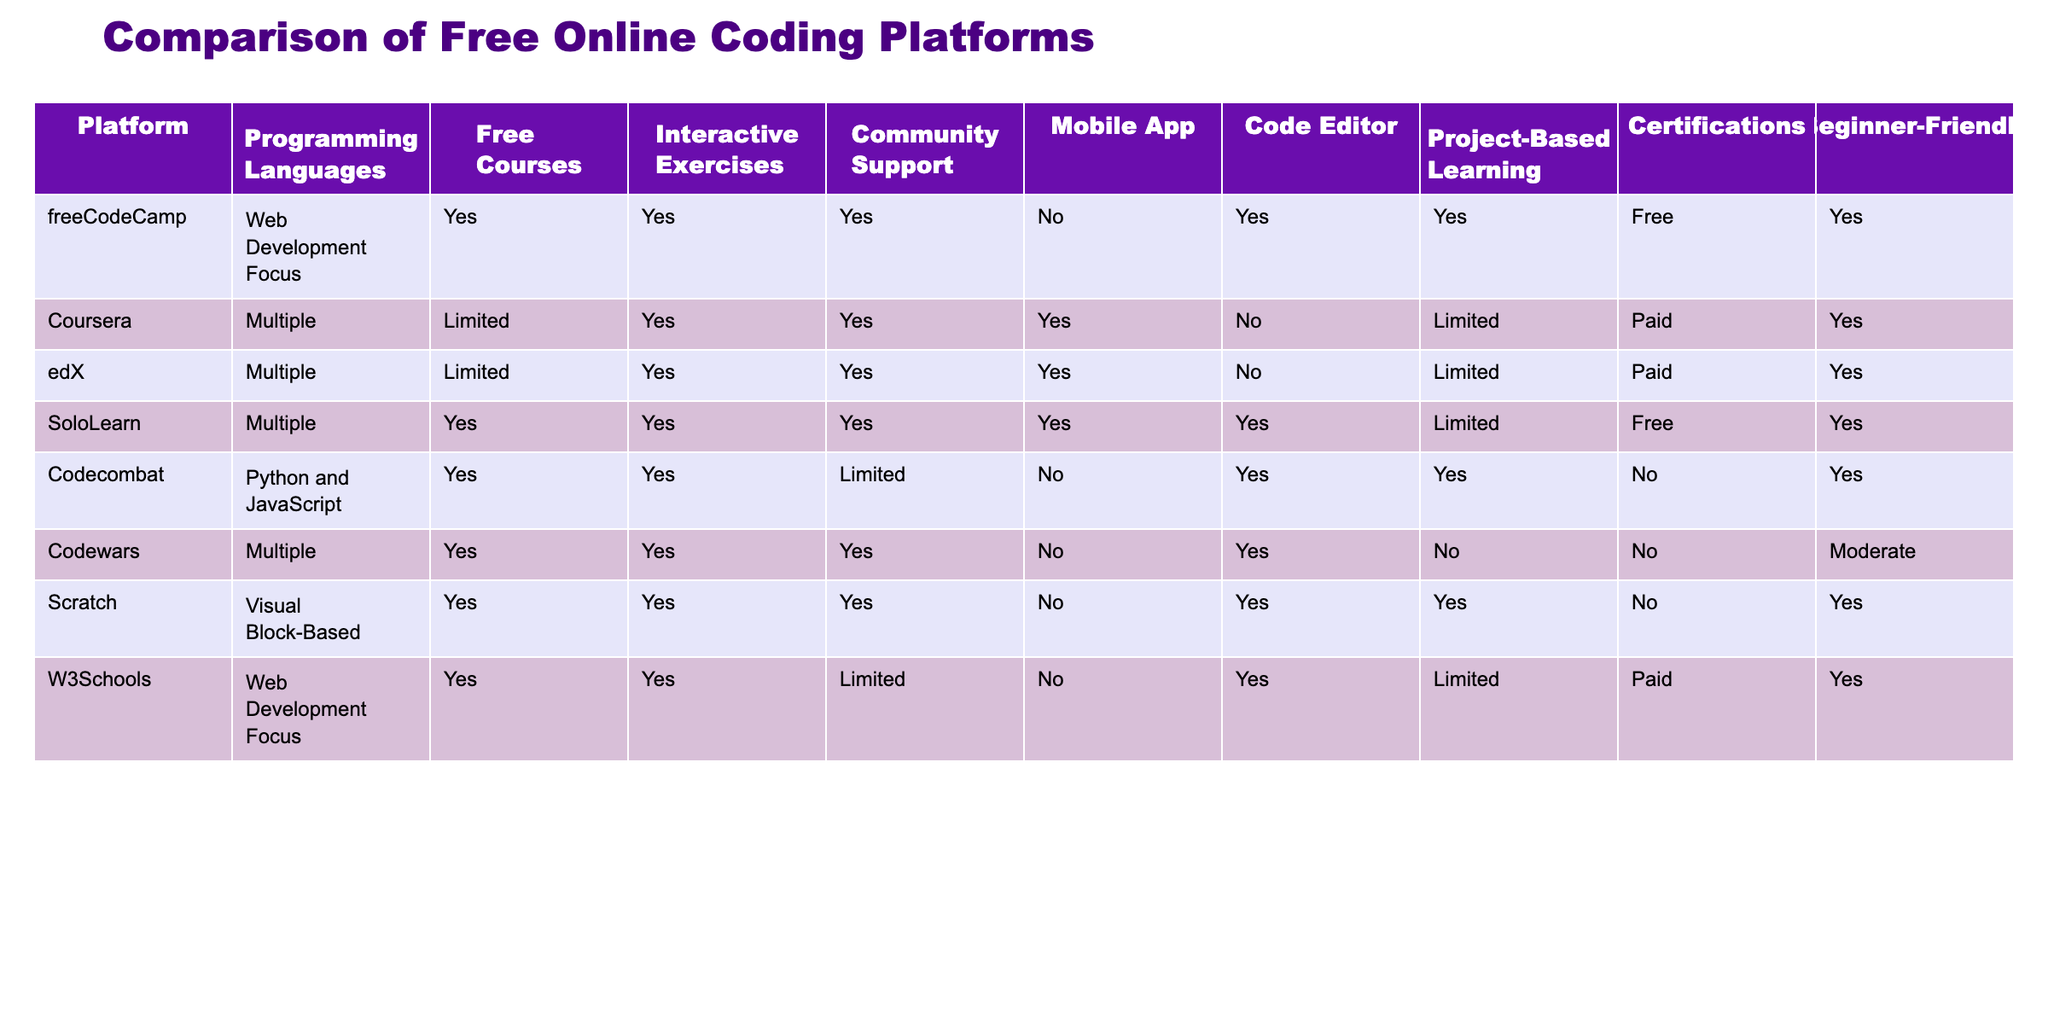What platforms offer project-based learning? By examining the column labeled "Project-Based Learning," I see which platforms have "Yes" listed. These platforms are freeCodeCamp, Codecombat, Scratch, and SoloLearn.
Answer: freeCodeCamp, Codecombat, Scratch, SoloLearn How many platforms provide a mobile app? I will count the platforms where the "Mobile App" column is marked "Yes." By scanning the data, I find that SoloLearn, Coursera, and edX provide a mobile app. This totals to three platforms.
Answer: 3 Is Scratch beginner-friendly? I will check the "Beginner-Friendly" column for Scratch and see that it indicates "Yes," meaning it is indeed beginner-friendly.
Answer: Yes Which platform has the most comprehensive community support? Looking at the "Community Support" column, I can see that "Yes" is noted for SoloLearn, freeCodeCamp, and Codewars. Among these, SoloLearn appears to have the most strong community support as indicated by the presence in multiple categories.
Answer: SoloLearn How many platforms do not offer certifications? By counting the entries in the "Certifications" column marked as "No," I find that Codecombat, Scratch, and Codewars have "No" listed under certifications. This shows that there are three platforms that do not offer certifications.
Answer: 3 What is the only platform that focuses on visual block-based programming? By reviewing the "Programming Languages" column, I see that Scratch is the only platform labeled as having a focus on visual block-based programming.
Answer: Scratch Which platform offers limited free courses and also has beginner-friendly programming? I will look for platforms that have "Limited" in the "Free Courses" column and check the "Beginner-Friendly" column to find any marked "Yes." The platforms matching this criterion are Coursera and edX.
Answer: Coursera, edX Calculate how many platforms support interactive exercises but do not offer a mobile app. First, I will identify the platforms that have "Yes" under "Interactive Exercises" and "No" under "Mobile App." Codewars and W3Schools satisfy these criteria, giving us a total of two platforms.
Answer: 2 